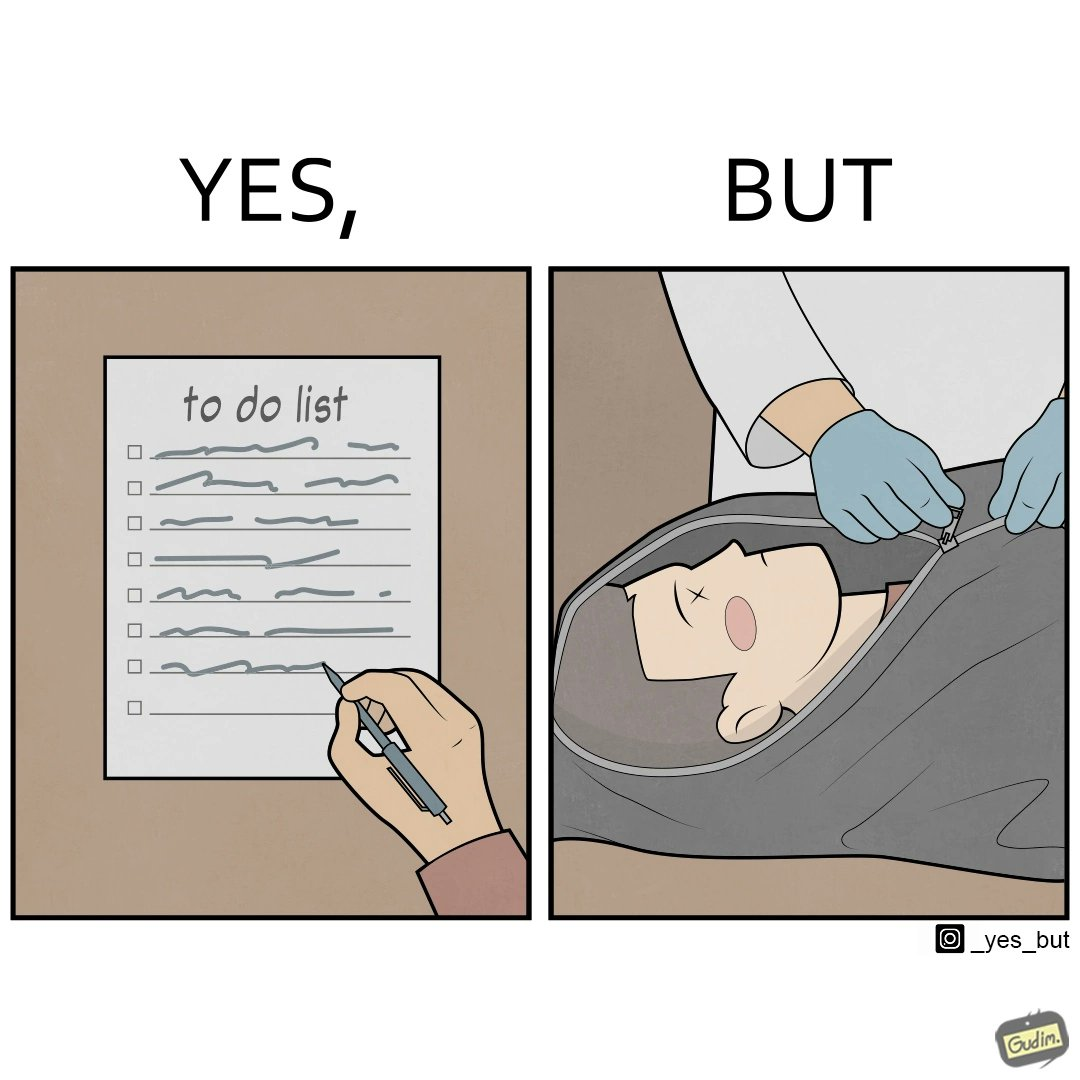Describe what you see in this image. The image is ironic, because in the first image it shows that someone plan their life in a to-do list but as the future is unknown anyone can never be sure whether he/she can complete their to-do lists 